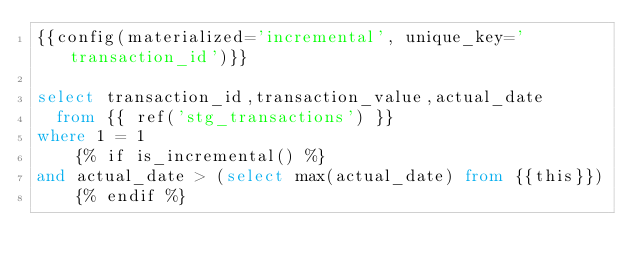<code> <loc_0><loc_0><loc_500><loc_500><_SQL_>{{config(materialized='incremental', unique_key='transaction_id')}}

select transaction_id,transaction_value,actual_date
  from {{ ref('stg_transactions') }}
where 1 = 1
    {% if is_incremental() %}
and actual_date > (select max(actual_date) from {{this}})
    {% endif %}</code> 